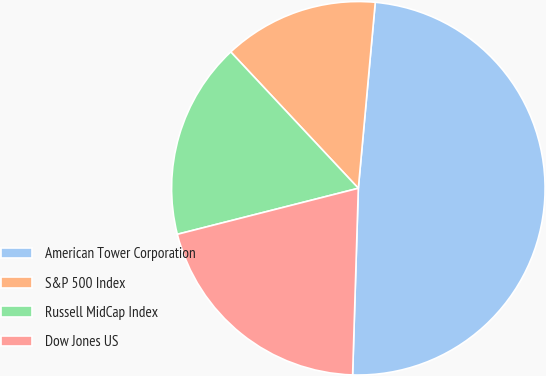<chart> <loc_0><loc_0><loc_500><loc_500><pie_chart><fcel>American Tower Corporation<fcel>S&P 500 Index<fcel>Russell MidCap Index<fcel>Dow Jones US<nl><fcel>49.04%<fcel>13.42%<fcel>16.99%<fcel>20.55%<nl></chart> 